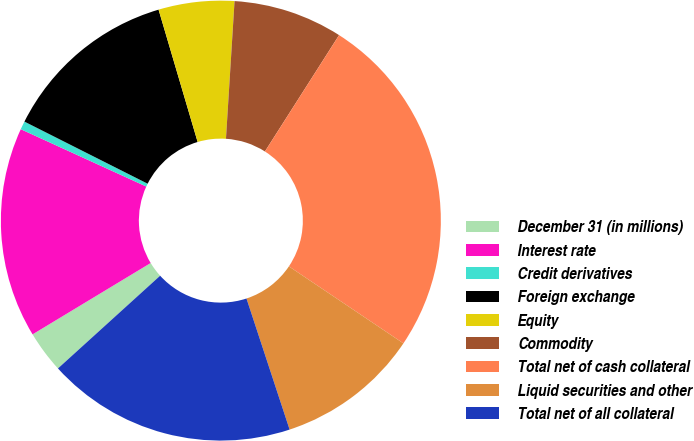<chart> <loc_0><loc_0><loc_500><loc_500><pie_chart><fcel>December 31 (in millions)<fcel>Interest rate<fcel>Credit derivatives<fcel>Foreign exchange<fcel>Equity<fcel>Commodity<fcel>Total net of cash collateral<fcel>Liquid securities and other<fcel>Total net of all collateral<nl><fcel>3.08%<fcel>15.47%<fcel>0.61%<fcel>13.0%<fcel>5.56%<fcel>8.04%<fcel>25.39%<fcel>10.52%<fcel>18.33%<nl></chart> 